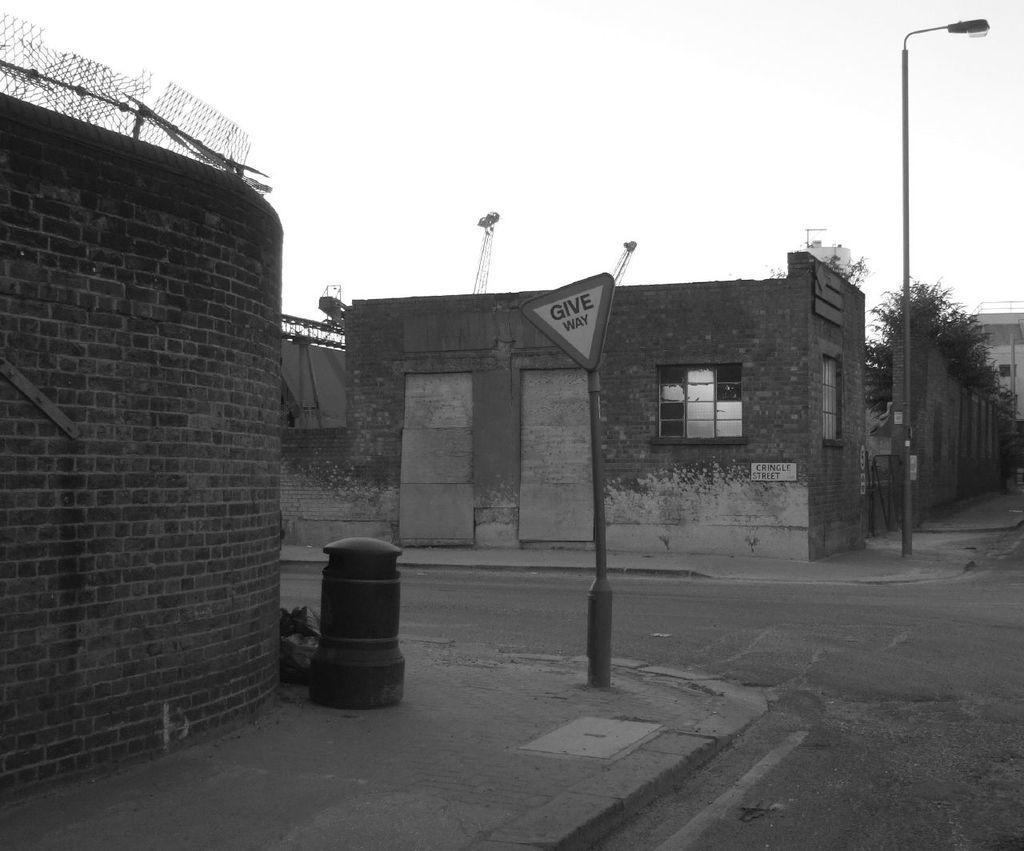Could you give a brief overview of what you see in this image? In this picture we can see the road, poles, buildings with windows, trees and in the background we can see the sky. 